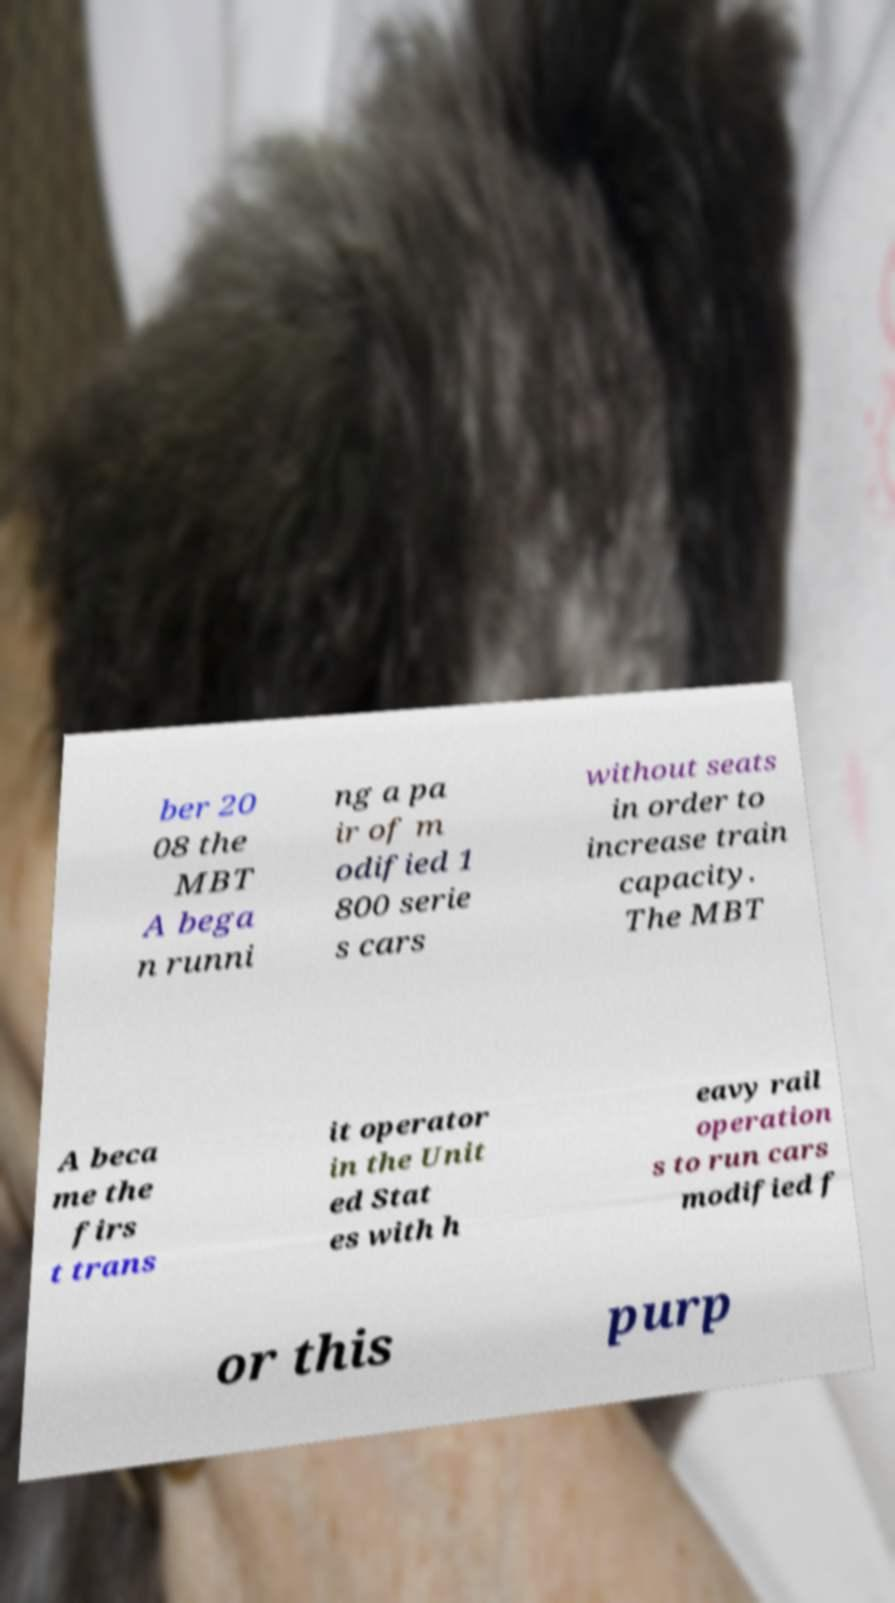Could you extract and type out the text from this image? ber 20 08 the MBT A bega n runni ng a pa ir of m odified 1 800 serie s cars without seats in order to increase train capacity. The MBT A beca me the firs t trans it operator in the Unit ed Stat es with h eavy rail operation s to run cars modified f or this purp 